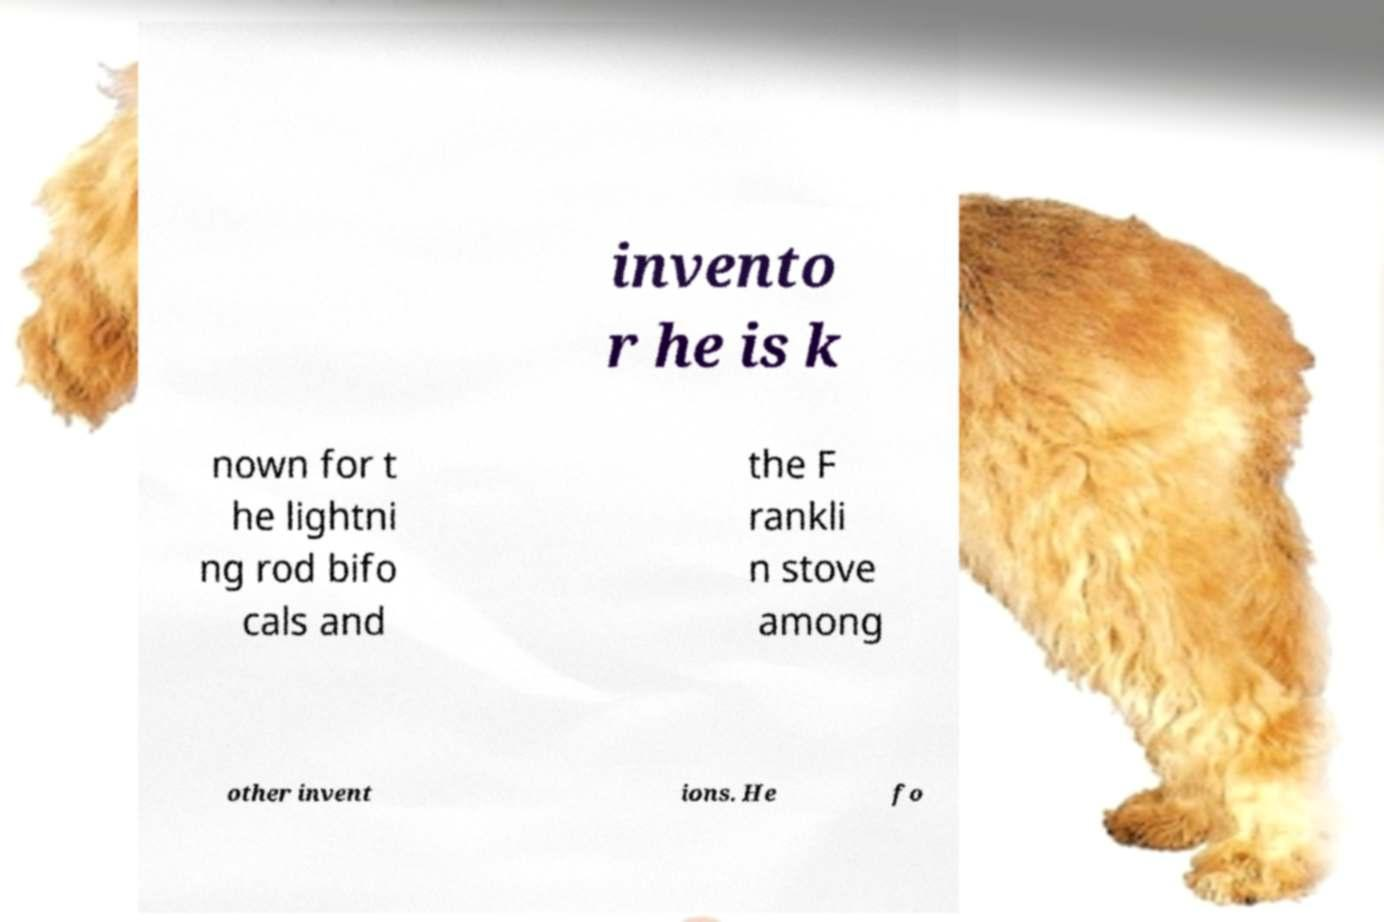Please read and relay the text visible in this image. What does it say? invento r he is k nown for t he lightni ng rod bifo cals and the F rankli n stove among other invent ions. He fo 